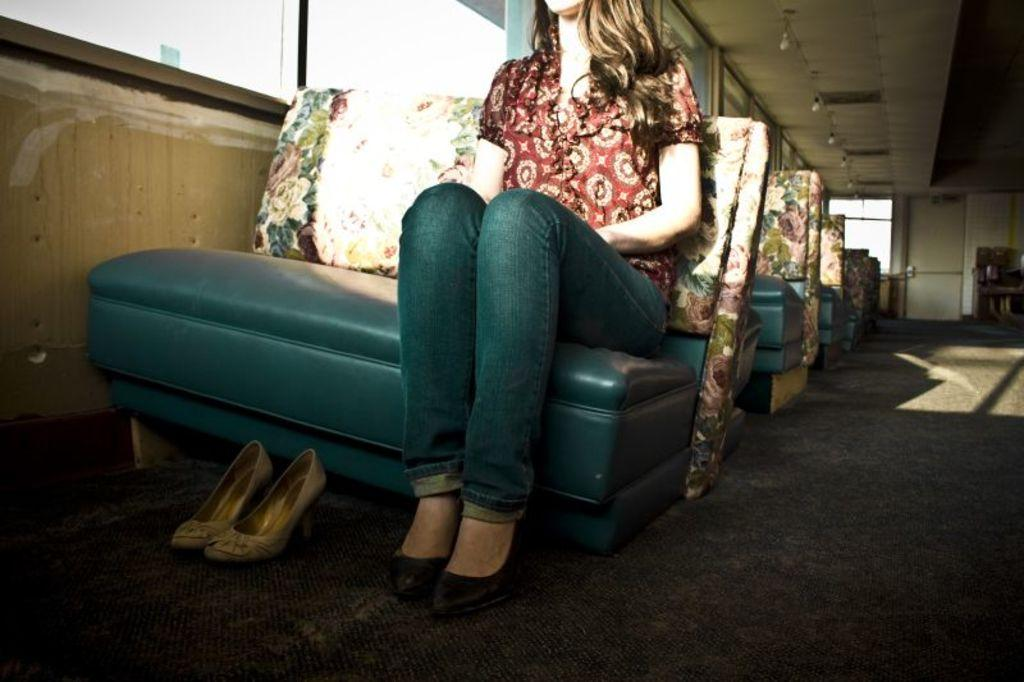What is the woman in the image doing? The woman is sitting on a seat in the image. What can be seen on the floor near the woman? Footwear is visible on the floor. What type of furniture is present in the image? Chairs are present in the image. What is on the ceiling in the image? There are lights on the ceiling. What surrounds the area where the woman is sitting? Walls are visible in the image. Can you describe any other objects in the image? There are other unspecified objects in the image. What type of club is the woman holding in the image? There is no club present in the image; the woman is sitting on a seat. Can you tell me how many bones are visible in the image? There are no bones visible in the image. 